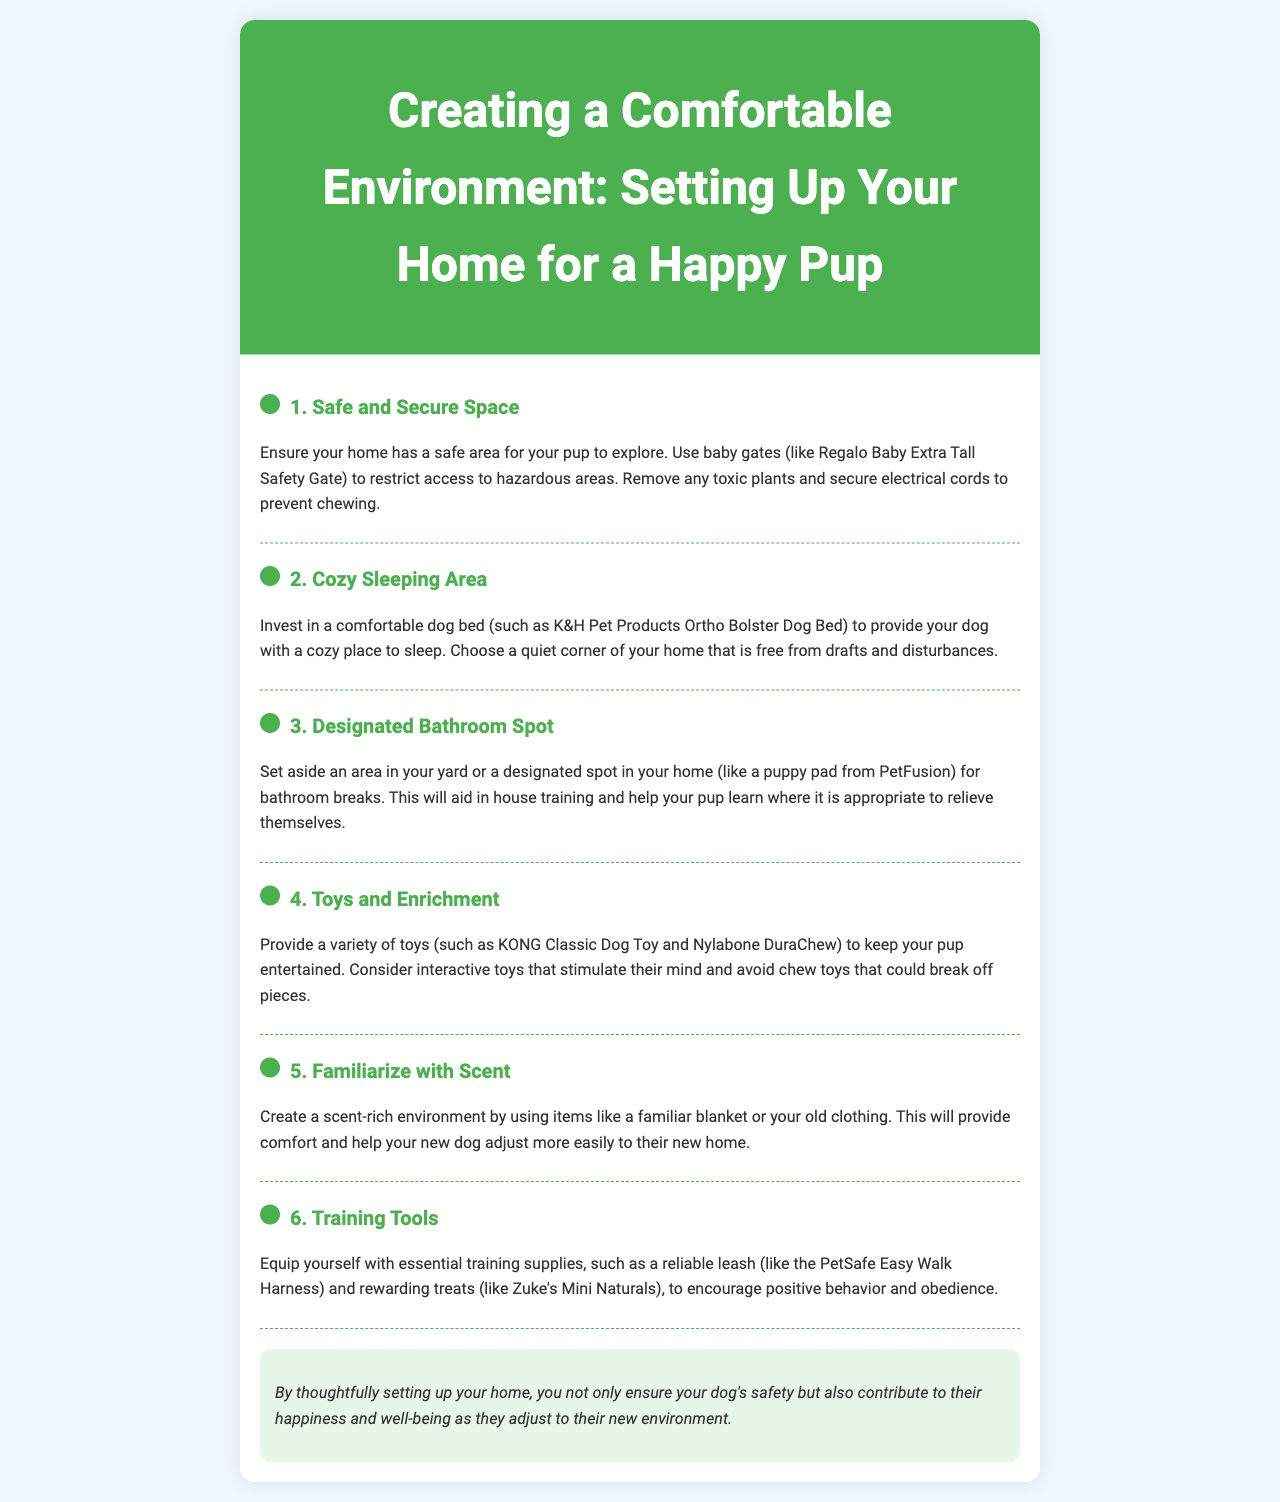what is the title of the brochure? The title of the brochure is presented prominently at the top of the document.
Answer: Creating a Comfortable Environment: Setting Up Your Home for a Happy Pup what is recommended for creating a safe space? The document suggests using baby gates to restrict access to hazardous areas.
Answer: baby gates which item is suggested for a cozy sleeping area? The brochure mentions a specific dog bed that can be purchased for comfort.
Answer: K&H Pet Products Ortho Bolster Dog Bed what is advised for helping with house training? The document suggests setting aside a specific area for bathroom breaks to assist with house training.
Answer: designated spot what type of toys should be avoided? The document warns against certain toys that may pose a risk to your dog.
Answer: chew toys that could break off pieces how can you create a scent-rich environment? The document describes a method to make the environment comforting for the dog using personal items.
Answer: familiar blanket or your old clothing what essential training tool is mentioned in the brochure? The brochure lists an important piece of equipment used for training dogs.
Answer: PetSafe Easy Walk Harness what is the primary purpose of setting up your home thoughtfully? The document concludes with a main benefit of carefully planning your dog's space.
Answer: safety and happiness 